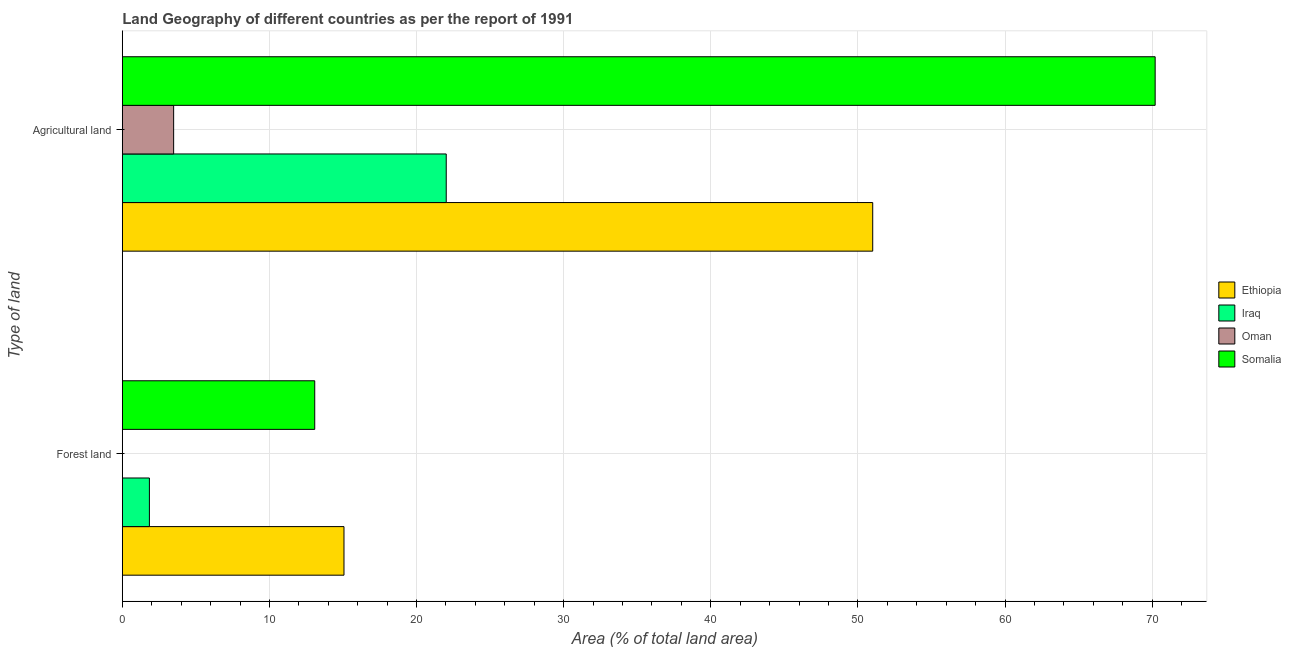How many different coloured bars are there?
Offer a very short reply. 4. How many bars are there on the 2nd tick from the bottom?
Give a very brief answer. 4. What is the label of the 2nd group of bars from the top?
Provide a succinct answer. Forest land. What is the percentage of land area under forests in Iraq?
Make the answer very short. 1.84. Across all countries, what is the maximum percentage of land area under forests?
Provide a succinct answer. 15.07. Across all countries, what is the minimum percentage of land area under agriculture?
Your answer should be compact. 3.49. In which country was the percentage of land area under forests maximum?
Provide a succinct answer. Ethiopia. In which country was the percentage of land area under agriculture minimum?
Your answer should be compact. Oman. What is the total percentage of land area under agriculture in the graph?
Offer a terse response. 146.72. What is the difference between the percentage of land area under agriculture in Somalia and that in Iraq?
Your answer should be very brief. 48.19. What is the difference between the percentage of land area under forests in Ethiopia and the percentage of land area under agriculture in Iraq?
Give a very brief answer. -6.95. What is the average percentage of land area under agriculture per country?
Provide a succinct answer. 36.68. What is the difference between the percentage of land area under agriculture and percentage of land area under forests in Oman?
Offer a very short reply. 3.48. In how many countries, is the percentage of land area under forests greater than 26 %?
Provide a succinct answer. 0. What is the ratio of the percentage of land area under forests in Somalia to that in Oman?
Your answer should be very brief. 2024.05. What does the 2nd bar from the top in Forest land represents?
Your answer should be very brief. Oman. What does the 2nd bar from the bottom in Agricultural land represents?
Keep it short and to the point. Iraq. Are all the bars in the graph horizontal?
Your answer should be very brief. Yes. Does the graph contain grids?
Ensure brevity in your answer.  Yes. Where does the legend appear in the graph?
Keep it short and to the point. Center right. How many legend labels are there?
Offer a very short reply. 4. How are the legend labels stacked?
Offer a very short reply. Vertical. What is the title of the graph?
Make the answer very short. Land Geography of different countries as per the report of 1991. What is the label or title of the X-axis?
Offer a terse response. Area (% of total land area). What is the label or title of the Y-axis?
Provide a short and direct response. Type of land. What is the Area (% of total land area) in Ethiopia in Forest land?
Ensure brevity in your answer.  15.07. What is the Area (% of total land area) of Iraq in Forest land?
Keep it short and to the point. 1.84. What is the Area (% of total land area) of Oman in Forest land?
Make the answer very short. 0.01. What is the Area (% of total land area) in Somalia in Forest land?
Give a very brief answer. 13.08. What is the Area (% of total land area) of Ethiopia in Agricultural land?
Your answer should be compact. 51.01. What is the Area (% of total land area) in Iraq in Agricultural land?
Ensure brevity in your answer.  22.02. What is the Area (% of total land area) in Oman in Agricultural land?
Offer a very short reply. 3.49. What is the Area (% of total land area) of Somalia in Agricultural land?
Offer a terse response. 70.2. Across all Type of land, what is the maximum Area (% of total land area) in Ethiopia?
Make the answer very short. 51.01. Across all Type of land, what is the maximum Area (% of total land area) in Iraq?
Give a very brief answer. 22.02. Across all Type of land, what is the maximum Area (% of total land area) in Oman?
Offer a terse response. 3.49. Across all Type of land, what is the maximum Area (% of total land area) of Somalia?
Your answer should be compact. 70.2. Across all Type of land, what is the minimum Area (% of total land area) of Ethiopia?
Provide a succinct answer. 15.07. Across all Type of land, what is the minimum Area (% of total land area) in Iraq?
Ensure brevity in your answer.  1.84. Across all Type of land, what is the minimum Area (% of total land area) in Oman?
Provide a short and direct response. 0.01. Across all Type of land, what is the minimum Area (% of total land area) of Somalia?
Your answer should be compact. 13.08. What is the total Area (% of total land area) in Ethiopia in the graph?
Offer a very short reply. 66.07. What is the total Area (% of total land area) in Iraq in the graph?
Ensure brevity in your answer.  23.86. What is the total Area (% of total land area) of Oman in the graph?
Provide a short and direct response. 3.5. What is the total Area (% of total land area) in Somalia in the graph?
Give a very brief answer. 83.28. What is the difference between the Area (% of total land area) in Ethiopia in Forest land and that in Agricultural land?
Provide a short and direct response. -35.94. What is the difference between the Area (% of total land area) of Iraq in Forest land and that in Agricultural land?
Your response must be concise. -20.18. What is the difference between the Area (% of total land area) of Oman in Forest land and that in Agricultural land?
Your answer should be very brief. -3.48. What is the difference between the Area (% of total land area) of Somalia in Forest land and that in Agricultural land?
Provide a short and direct response. -57.12. What is the difference between the Area (% of total land area) of Ethiopia in Forest land and the Area (% of total land area) of Iraq in Agricultural land?
Make the answer very short. -6.95. What is the difference between the Area (% of total land area) in Ethiopia in Forest land and the Area (% of total land area) in Oman in Agricultural land?
Your response must be concise. 11.58. What is the difference between the Area (% of total land area) in Ethiopia in Forest land and the Area (% of total land area) in Somalia in Agricultural land?
Make the answer very short. -55.14. What is the difference between the Area (% of total land area) of Iraq in Forest land and the Area (% of total land area) of Oman in Agricultural land?
Offer a terse response. -1.65. What is the difference between the Area (% of total land area) of Iraq in Forest land and the Area (% of total land area) of Somalia in Agricultural land?
Offer a very short reply. -68.36. What is the difference between the Area (% of total land area) of Oman in Forest land and the Area (% of total land area) of Somalia in Agricultural land?
Your answer should be very brief. -70.2. What is the average Area (% of total land area) of Ethiopia per Type of land?
Your answer should be very brief. 33.04. What is the average Area (% of total land area) of Iraq per Type of land?
Offer a terse response. 11.93. What is the average Area (% of total land area) in Oman per Type of land?
Provide a succinct answer. 1.75. What is the average Area (% of total land area) of Somalia per Type of land?
Your response must be concise. 41.64. What is the difference between the Area (% of total land area) of Ethiopia and Area (% of total land area) of Iraq in Forest land?
Your answer should be compact. 13.23. What is the difference between the Area (% of total land area) of Ethiopia and Area (% of total land area) of Oman in Forest land?
Your answer should be compact. 15.06. What is the difference between the Area (% of total land area) in Ethiopia and Area (% of total land area) in Somalia in Forest land?
Offer a very short reply. 1.99. What is the difference between the Area (% of total land area) in Iraq and Area (% of total land area) in Oman in Forest land?
Provide a succinct answer. 1.83. What is the difference between the Area (% of total land area) in Iraq and Area (% of total land area) in Somalia in Forest land?
Give a very brief answer. -11.24. What is the difference between the Area (% of total land area) of Oman and Area (% of total land area) of Somalia in Forest land?
Give a very brief answer. -13.07. What is the difference between the Area (% of total land area) of Ethiopia and Area (% of total land area) of Iraq in Agricultural land?
Your answer should be very brief. 28.99. What is the difference between the Area (% of total land area) of Ethiopia and Area (% of total land area) of Oman in Agricultural land?
Offer a very short reply. 47.52. What is the difference between the Area (% of total land area) in Ethiopia and Area (% of total land area) in Somalia in Agricultural land?
Offer a terse response. -19.2. What is the difference between the Area (% of total land area) of Iraq and Area (% of total land area) of Oman in Agricultural land?
Your answer should be compact. 18.53. What is the difference between the Area (% of total land area) of Iraq and Area (% of total land area) of Somalia in Agricultural land?
Give a very brief answer. -48.19. What is the difference between the Area (% of total land area) in Oman and Area (% of total land area) in Somalia in Agricultural land?
Ensure brevity in your answer.  -66.71. What is the ratio of the Area (% of total land area) in Ethiopia in Forest land to that in Agricultural land?
Provide a succinct answer. 0.3. What is the ratio of the Area (% of total land area) in Iraq in Forest land to that in Agricultural land?
Your response must be concise. 0.08. What is the ratio of the Area (% of total land area) in Oman in Forest land to that in Agricultural land?
Keep it short and to the point. 0. What is the ratio of the Area (% of total land area) of Somalia in Forest land to that in Agricultural land?
Make the answer very short. 0.19. What is the difference between the highest and the second highest Area (% of total land area) of Ethiopia?
Offer a very short reply. 35.94. What is the difference between the highest and the second highest Area (% of total land area) of Iraq?
Keep it short and to the point. 20.18. What is the difference between the highest and the second highest Area (% of total land area) in Oman?
Offer a very short reply. 3.48. What is the difference between the highest and the second highest Area (% of total land area) of Somalia?
Your answer should be very brief. 57.12. What is the difference between the highest and the lowest Area (% of total land area) in Ethiopia?
Your answer should be very brief. 35.94. What is the difference between the highest and the lowest Area (% of total land area) of Iraq?
Your response must be concise. 20.18. What is the difference between the highest and the lowest Area (% of total land area) in Oman?
Offer a very short reply. 3.48. What is the difference between the highest and the lowest Area (% of total land area) in Somalia?
Your answer should be compact. 57.12. 